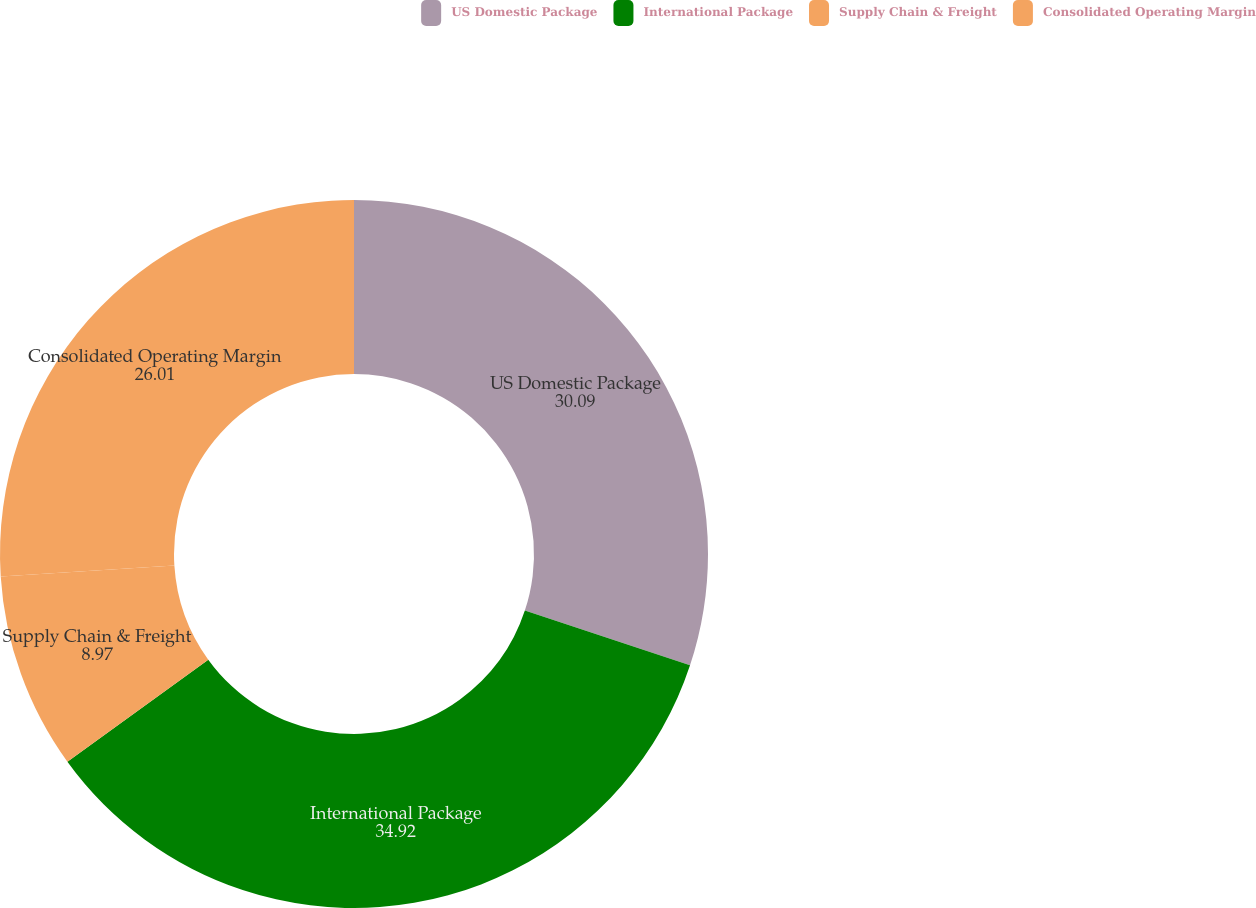Convert chart. <chart><loc_0><loc_0><loc_500><loc_500><pie_chart><fcel>US Domestic Package<fcel>International Package<fcel>Supply Chain & Freight<fcel>Consolidated Operating Margin<nl><fcel>30.09%<fcel>34.92%<fcel>8.97%<fcel>26.01%<nl></chart> 